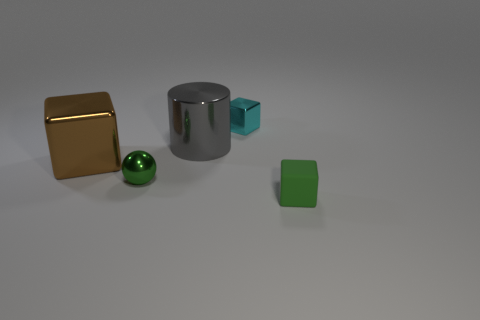There is a rubber thing that is the same color as the metal ball; what size is it? The rubber object, which shares the same green hue as the metal ball, is small-sized, comparable to a standard eraser. It appears to be a cube that could comfortably fit within the grasp of an adult's hand. 